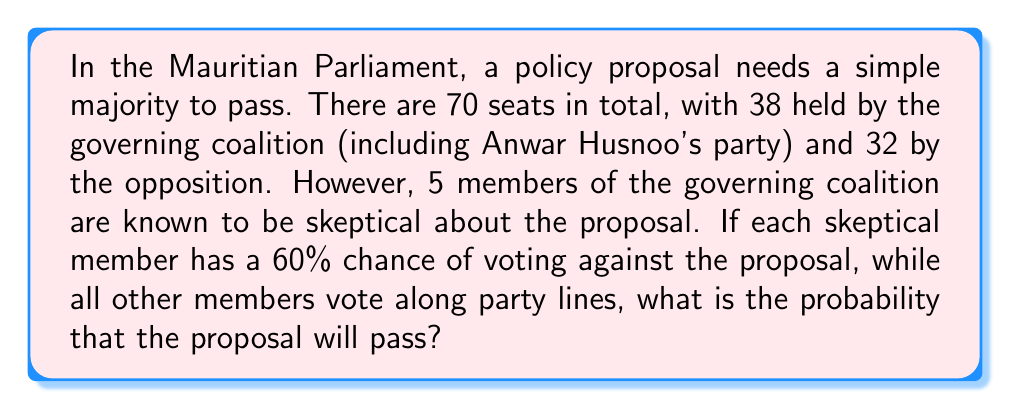Give your solution to this math problem. Let's approach this step-by-step:

1) First, we need to determine the minimum number of votes required for the proposal to pass. With 70 seats, a simple majority requires:

   $$\text{Minimum votes} = \left\lfloor\frac{70}{2}\right\rfloor + 1 = 35 + 1 = 36$$

2) The governing coalition has 38 seats, but 5 members are skeptical. So we have:
   - 33 guaranteed 'yes' votes
   - 32 guaranteed 'no' votes
   - 5 uncertain votes

3) For the proposal to pass, we need at least 3 of the 5 skeptical members to vote 'yes'.

4) The probability of a skeptical member voting 'yes' is $1 - 0.60 = 0.40$ or 40%.

5) This scenario follows a binomial probability distribution. We need to calculate the probability of getting 3, 4, or 5 'yes' votes out of 5 trials, where each trial has a 40% chance of success.

6) The probability is given by:

   $$P(\text{pass}) = P(X \geq 3) = P(X=3) + P(X=4) + P(X=5)$$

   where $X$ is the number of 'yes' votes from skeptical members.

7) Using the binomial probability formula:

   $$P(X=k) = \binom{n}{k} p^k (1-p)^{n-k}$$

   where $n=5$, $p=0.40$, and $k = 3, 4, \text{ or } 5$

8) Calculating each term:

   $$P(X=3) = \binom{5}{3} (0.40)^3 (0.60)^2 = 0.2304$$
   $$P(X=4) = \binom{5}{4} (0.40)^4 (0.60)^1 = 0.0768$$
   $$P(X=5) = \binom{5}{5} (0.40)^5 (0.60)^0 = 0.0102$$

9) Sum these probabilities:

   $$P(\text{pass}) = 0.2304 + 0.0768 + 0.0102 = 0.3174$$
Answer: The probability that the proposal will pass is approximately 0.3174 or 31.74%. 